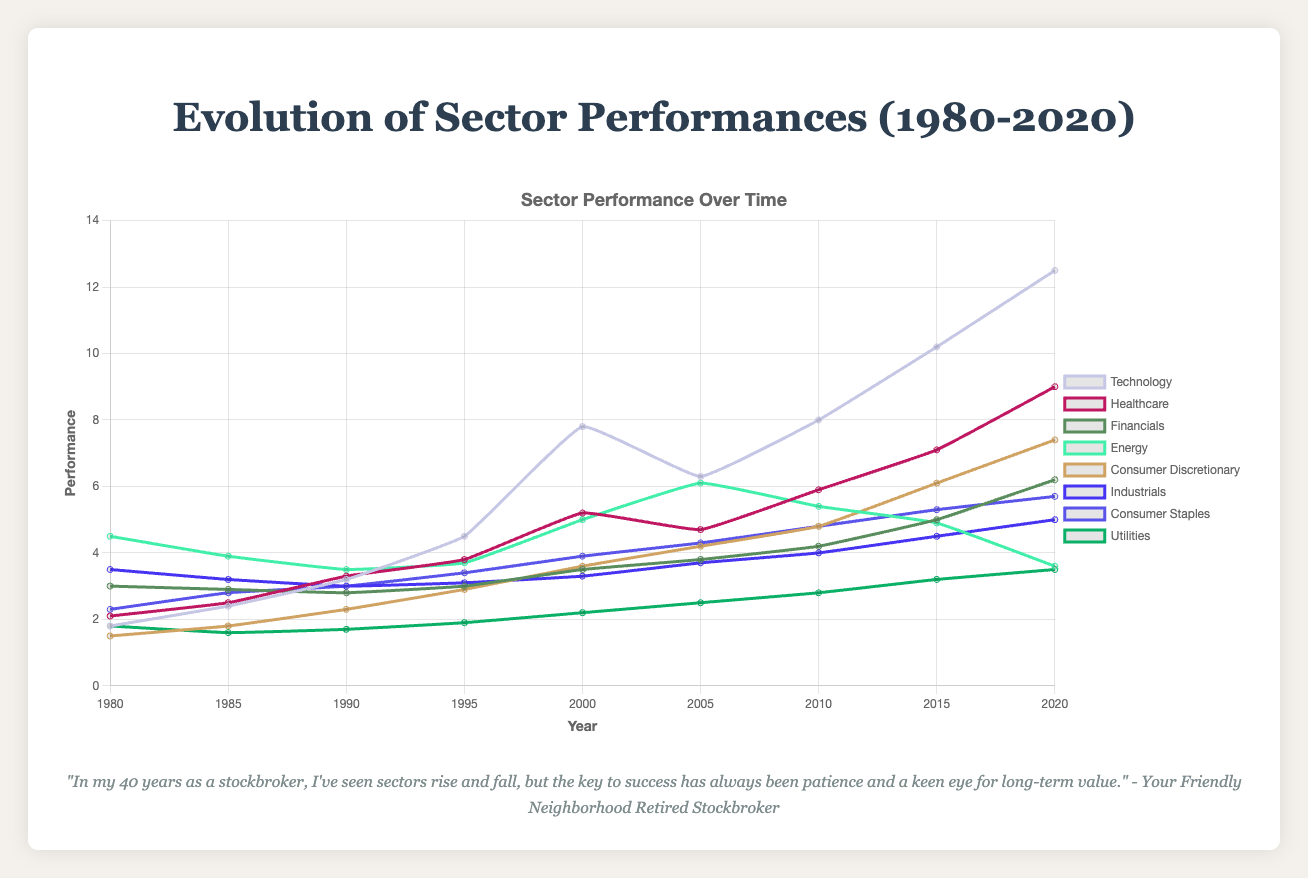Which sector had the highest performance in 2020? Look at the line chart for the year 2020 and identify which sector has the highest line. The Technology sector is the highest.
Answer: Technology How did the Energy sector's performance change from 1980 to 2020? Observe the line corresponding to the Energy sector from the year 1980 to 2020. In 1980, the performance was 4.5, and in 2020, it was 3.6. This indicates a decrease.
Answer: Decreased Between 2000 and 2005, which sector experienced the largest decrease in performance? Compare the difference in performance between 2000 and 2005 for all sectors. Technology decreased from 7.8 to 6.3, which is the largest drop compared to other sectors.
Answer: Technology Which sector shows the most consistent upward trend from 1980 to 2020? Look for the sector with the smoothest and most consistent increase in the line chart. The Technology sector shows a steady increase without any major dips.
Answer: Technology What was the average performance of the Healthcare sector across all years displayed? Add up the performance values of the Healthcare sector for all years and divide by the number of years. (2.1 + 2.5 + 3.3 + 3.8 + 5.2 + 4.7 + 5.9 + 7.1 + 9.0) / 9 = 4.84.
Answer: 4.84 How did the performance of the Financials sector in 2000 compare to that of 2010? Look at the Financials sector performance values for the years 2000 and 2010. In 2000, the performance was 3.5, and in 2010, it was 4.2. The performance increased.
Answer: Increased Which sector had a higher performance in 1995: Industrials or Consumer Staples? Compare the performance values for Industrials and Consumer Staples in 1995. Industrials had 3.1, and Consumer Staples had 3.4.
Answer: Consumer Staples Between 1990 and 2020, which sector grew the most in terms of absolute performance? Calculate the difference in performance between 1990 and 2020 for each sector. Technology grew by 12.5 - 3.2 = 9.3, which is the largest increase.
Answer: Technology Which two sectors had nearly equal performance in 1980? Look at the performance values for each sector in 1980 and identify any two that are similar. Technology and Utilities both had a performance of 1.8.
Answer: Technology and Utilities What is the performance difference between Healthcare and Energy sectors in 2020? Subtract the performance value of the Energy sector in 2020 from that of the Healthcare sector. 9.0 (Healthcare) - 3.6 (Energy) = 5.4.
Answer: 5.4 